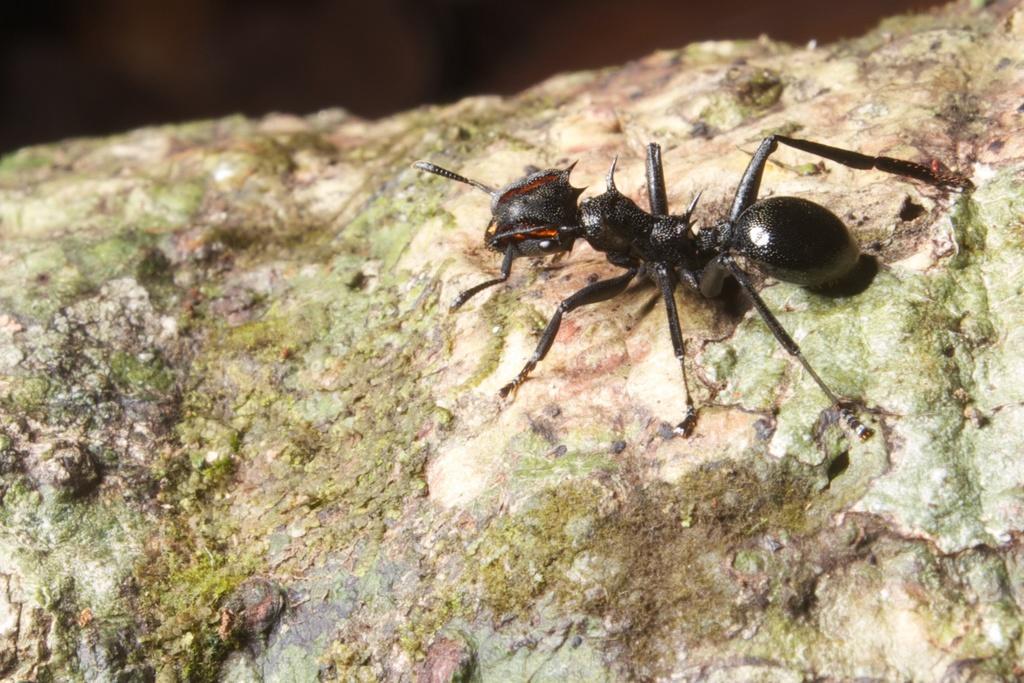In one or two sentences, can you explain what this image depicts? In this picture I can see there is a black ant on to left and it has legs, head and body. There is a stone here. 